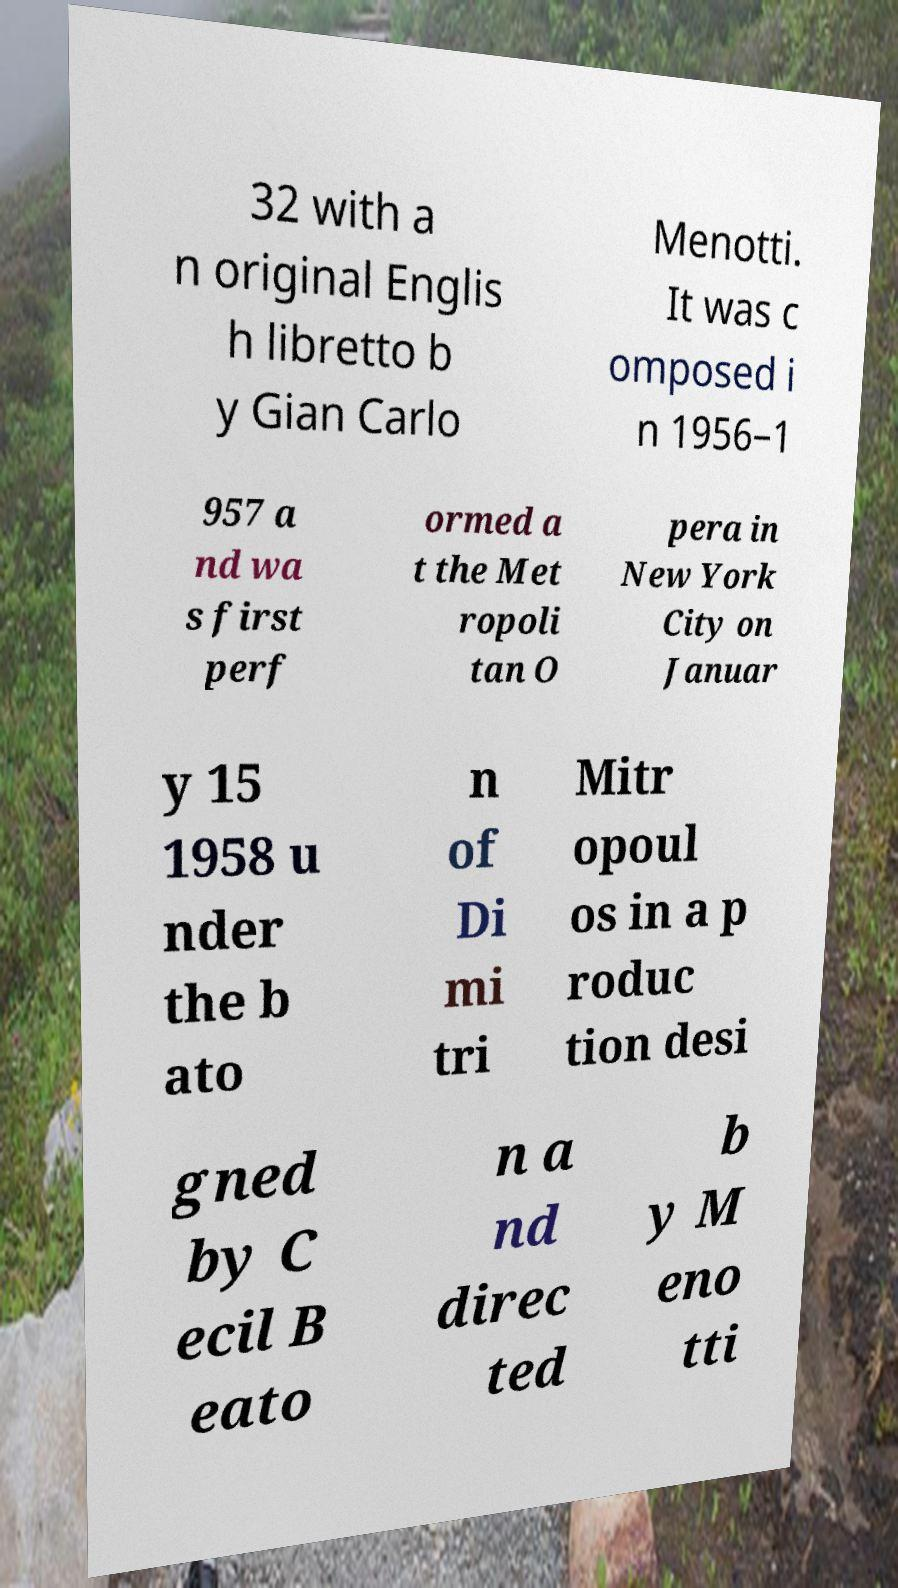I need the written content from this picture converted into text. Can you do that? 32 with a n original Englis h libretto b y Gian Carlo Menotti. It was c omposed i n 1956–1 957 a nd wa s first perf ormed a t the Met ropoli tan O pera in New York City on Januar y 15 1958 u nder the b ato n of Di mi tri Mitr opoul os in a p roduc tion desi gned by C ecil B eato n a nd direc ted b y M eno tti 